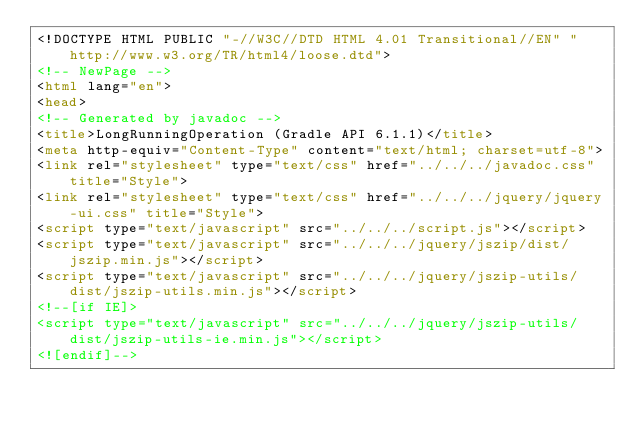Convert code to text. <code><loc_0><loc_0><loc_500><loc_500><_HTML_><!DOCTYPE HTML PUBLIC "-//W3C//DTD HTML 4.01 Transitional//EN" "http://www.w3.org/TR/html4/loose.dtd">
<!-- NewPage -->
<html lang="en">
<head>
<!-- Generated by javadoc -->
<title>LongRunningOperation (Gradle API 6.1.1)</title>
<meta http-equiv="Content-Type" content="text/html; charset=utf-8">
<link rel="stylesheet" type="text/css" href="../../../javadoc.css" title="Style">
<link rel="stylesheet" type="text/css" href="../../../jquery/jquery-ui.css" title="Style">
<script type="text/javascript" src="../../../script.js"></script>
<script type="text/javascript" src="../../../jquery/jszip/dist/jszip.min.js"></script>
<script type="text/javascript" src="../../../jquery/jszip-utils/dist/jszip-utils.min.js"></script>
<!--[if IE]>
<script type="text/javascript" src="../../../jquery/jszip-utils/dist/jszip-utils-ie.min.js"></script>
<![endif]--></code> 